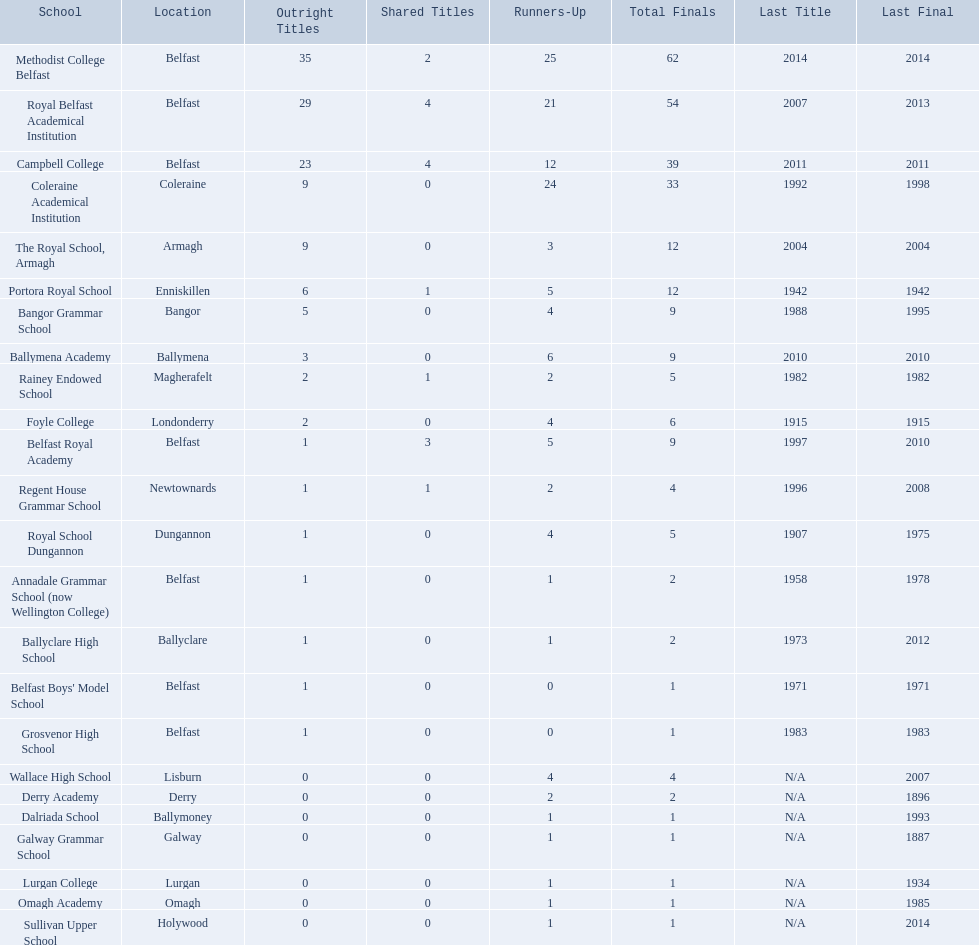What is the total number of schools? Methodist College Belfast, Royal Belfast Academical Institution, Campbell College, Coleraine Academical Institution, The Royal School, Armagh, Portora Royal School, Bangor Grammar School, Ballymena Academy, Rainey Endowed School, Foyle College, Belfast Royal Academy, Regent House Grammar School, Royal School Dungannon, Annadale Grammar School (now Wellington College), Ballyclare High School, Belfast Boys' Model School, Grosvenor High School, Wallace High School, Derry Academy, Dalriada School, Galway Grammar School, Lurgan College, Omagh Academy, Sullivan Upper School. How many absolute championships does coleraine academical institution possess? 9. Which other educational institution has an equal number of absolute championships? The Royal School, Armagh. 